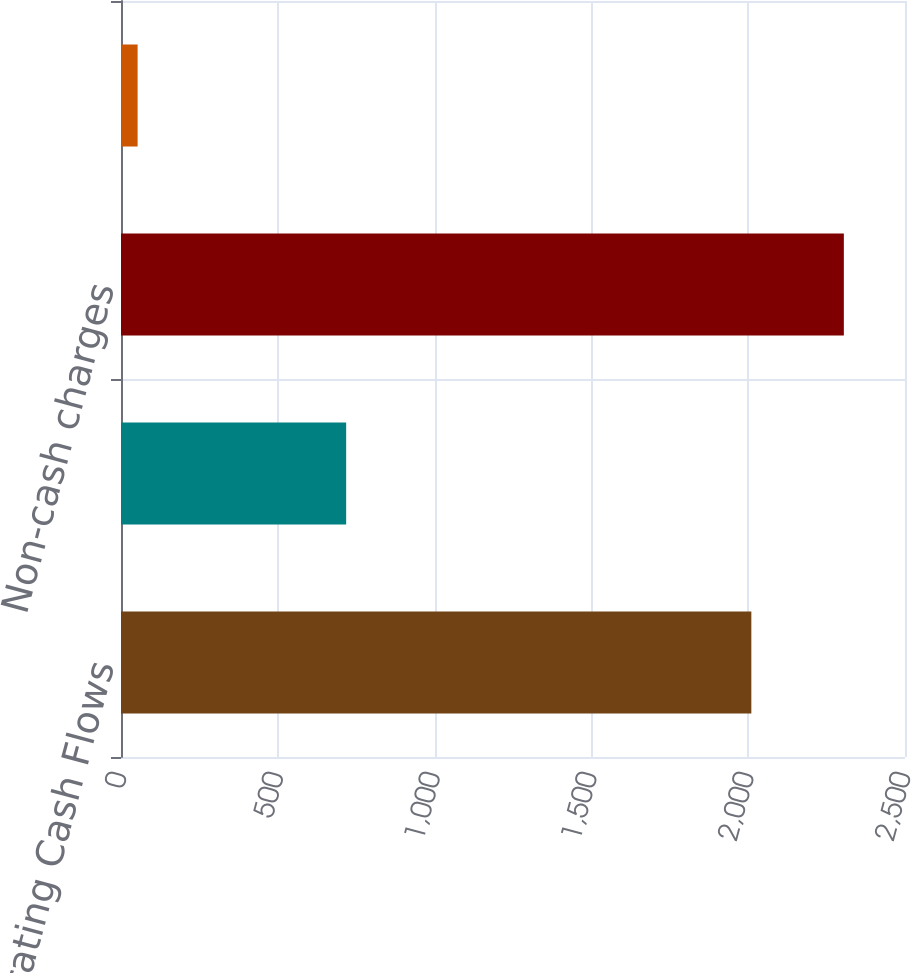<chart> <loc_0><loc_0><loc_500><loc_500><bar_chart><fcel>Operating Cash Flows<fcel>Net income<fcel>Non-cash charges<fcel>Working capital and other<nl><fcel>2010<fcel>718<fcel>2305<fcel>53<nl></chart> 